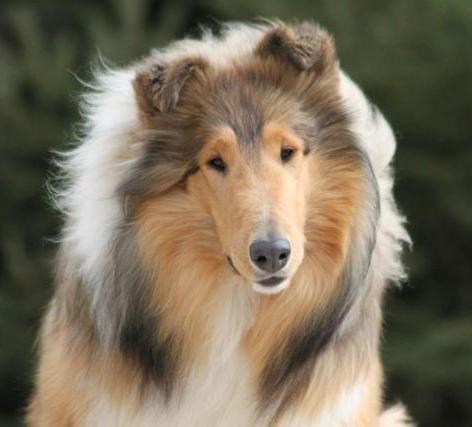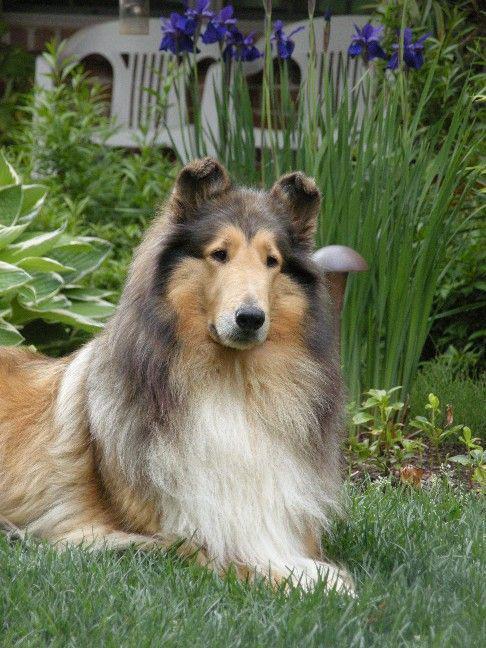The first image is the image on the left, the second image is the image on the right. For the images displayed, is the sentence "An adult collie dog poses in a scene with vibrant flowers." factually correct? Answer yes or no. Yes. The first image is the image on the left, the second image is the image on the right. For the images displayed, is the sentence "One of the dogs is standing in the grass." factually correct? Answer yes or no. No. 